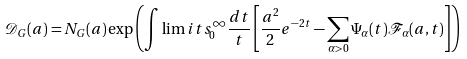Convert formula to latex. <formula><loc_0><loc_0><loc_500><loc_500>\mathcal { D } _ { G } ( a ) = N _ { G } ( a ) \exp \left ( \int \lim i t s _ { 0 } ^ { \infty } \frac { d t } { t } \left [ \frac { a ^ { 2 } } { 2 } e ^ { - 2 t } - \sum _ { \alpha > 0 } \Psi _ { \alpha } ( t ) \mathcal { F } _ { \alpha } ( a , t ) \right ] \right )</formula> 